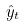Convert formula to latex. <formula><loc_0><loc_0><loc_500><loc_500>\hat { y } _ { t }</formula> 